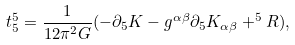Convert formula to latex. <formula><loc_0><loc_0><loc_500><loc_500>t _ { 5 } ^ { 5 } = \frac { 1 } { 1 2 \pi ^ { 2 } G } ( - \partial _ { 5 } K - g ^ { \alpha \beta } \partial _ { 5 } K _ { \alpha \beta } + ^ { 5 } R ) ,</formula> 